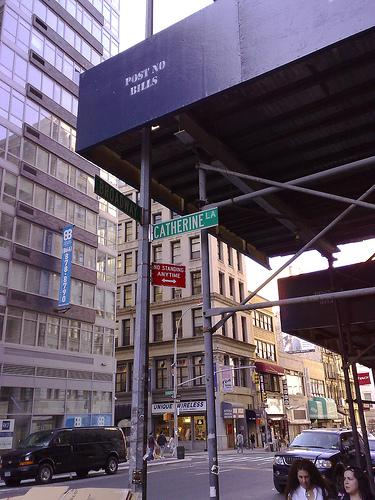List the primary objects in this scene. Couples heads, parked van, street signs, pedestrians, parked SUV, and windows in a building. What are the two women doing in the image? Two women are talking to each other in the image. Analyze the image for pedestrian activity and highlight their actions. A pedestrian crossing the street, a woman walking down the sidewalk, and people walking in the intersection are present in the image. State the image's predominant sentiment or mood. The image has a busy and urban street vibe. Count the number of street signs in the image. There are seven street signs in the image. Mention an unusual object seen in the scene and describe its appearance. "Post no bills" stenciled on an overhang, it is a white text on a blue metal background. Describe the business-related elements within the picture. A business promotional sign, a blue sign on a building, and a white and blue sign for the business are present in the image. How many vehicles can be seen parked on the street? There are four vehicles parked on the street. Infer what type of location this image is taken in? The image is taken in an urban street or city setting with buildings, vehicles, signs, and pedestrians. Detect and list all the light-related objects in the image. A light on a pole and a traffic light in the background are present in the image. What is the woman walking down the sidewalk's hair like? long curly hair What type of vehicle is parked beside the road? van Is the black van parked or in motion? parked Marvel at the impressive graffiti art showcasing multiple vibrant colors on the side of the building. None of the image captions refer to graffiti or any kind of art on the building walls. The closest mention could be the "writing on a blue metal," but that doesn't seem to be graffiti. Describe the background street sign's color and text. green and white catherine la street sign Take a closer look at the giant billboard advertising a new movie on the rooftop of the building on the right. No billboards or movie advertisements are described in the image captions. All signs mentioned are related to streets or small business promotions. Create a sentence about a sign in the image using these keywords: business promotional, blue, white. A blue and white business promotional sign is displayed in the image. Can you spot the pink bicycle leaning against the wall in the center of the image? The image contains several vehicles like vans and SUVs, but there is no mention of a bicycle, let alone a pink one. What is the color of the awning on the building? dark red Have you seen the adorable golden retriever playing with its frisbee near the crosswalk? There is no mention of any animals or pets, such as a golden retriever, or objects like frisbees, in the provided image captions. Identify the objects located in the intersection. white cross walk, people walking What is written on the awning? post no bills Identify and describe the tallest light structure in the image.  tall light beside the road on a metal pole Is the pedestrian on the sidewalk walking alone or with someone else? alone What type of vehicle is parked across the street from the awning? black van Create a short narrative that includes a pedestrian crossing the street and a van parked by the curb. As the pedestrian cautiously crossed the street, he noticed a black van parked by the curb, waiting for its owner to return. What are the two women in the image doing? talking to each other Choose the correct description for the sign in the image: a) a blue sign on a building, b) a red sign on a pole, c) a green sign on a tree.  a) a blue sign on a building Relate the words "long curly hair" to a subject in the image. the two women talking to each other Describe the vehicle parked under the awning. black suv Notice the magnificent marble fountain with an angel in the middle of the square. There is no mention of any fountains, marble structures or statues of angels in any of the image captions. Write a descriptive caption for a sign on a pole in the image. a green street name sign on a metal pole Can you count the flamingo decorations hanging along the street from the lamp posts? No, it's not mentioned in the image. 